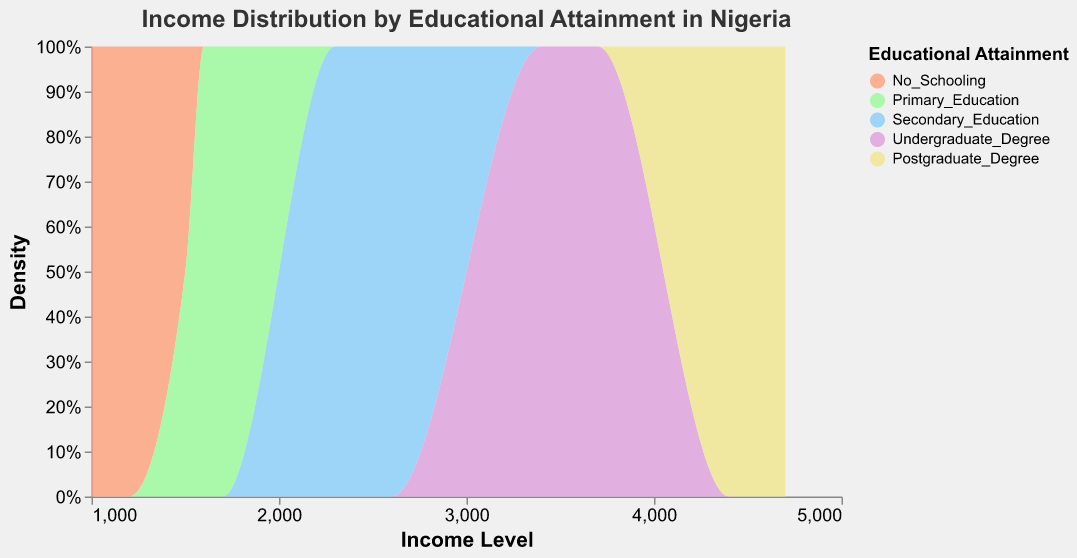What's the title of the figure? The title of the figure is usually found at the top, above the actual plot. In this case, it states "Income Distribution by Educational Attainment in Nigeria".
Answer: Income Distribution by Educational Attainment in Nigeria What does the x-axis represent in the figure? The x-axis typically shows the range of values being measured. In this figure, it represents different income levels.
Answer: Income Level What does the y-axis represent in the figure? The y-axis generally indicates the frequency or density of the values. Here, it represents the density, which shows how incomes are distributed across different educational attainments.
Answer: Density Which color represents the income distribution for individuals with "No Schooling"? Each educational attainment category is represented by a specific color. For "No Schooling", the color used is salmon.
Answer: Salmon Which educational attainment category has the highest income level? The highest income level is visually noted by the rightmost position on the x-axis. "Postgraduate Degree" appears in this position, indicating the highest income level of around 4500-4700.
Answer: Postgraduate Degree Which educational attainment category has the lowest income level? The lowest income level can be identified as the leftmost position on the x-axis. "No Schooling" appears in this position, indicating the lowest income levels of around 1000-1500.
Answer: No Schooling How does the income distribution for "Secondary Education" compare to "Undergraduate Degree"? The income levels for "Secondary Education" range from 2300 to 2600, while those for "Undergraduate Degree" range from 3400 to 3700. This indicates that "Undergraduate Degree" generally has higher income levels than "Secondary Education".
Answer: Undergraduate Degree has higher income levels What is the pattern of income level increase with educational attainment? By examining the plot, we can see that as educational attainment increases from "No Schooling" to "Postgraduate Degree", the income levels also increase progressively. This is visually shown by the gradual rightward shift in the density.
Answer: Income levels increase with education Which income level has the highest density in the "Primary Education" category? The highest density is indicated by the peak of the area for "Primary Education". This peak occurs around an income level of approximately 1600-1700.
Answer: 1600-1700 Which educational attainment category has the most spread-out income distribution? The most spread-out distribution is indicated by the broadest range along the x-axis. "Postgraduate Degree" displays a broad range from 4400 to 4700, suggesting the most spread-out income distribution.
Answer: Postgraduate Degree 